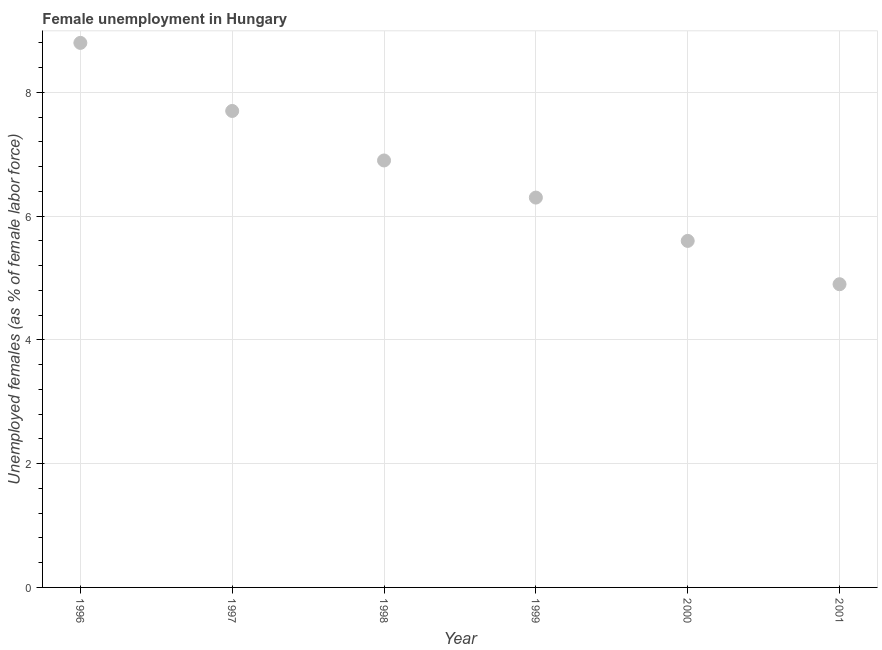What is the unemployed females population in 1999?
Your answer should be compact. 6.3. Across all years, what is the maximum unemployed females population?
Your answer should be compact. 8.8. Across all years, what is the minimum unemployed females population?
Provide a short and direct response. 4.9. What is the sum of the unemployed females population?
Give a very brief answer. 40.2. What is the difference between the unemployed females population in 1996 and 2001?
Ensure brevity in your answer.  3.9. What is the average unemployed females population per year?
Provide a succinct answer. 6.7. What is the median unemployed females population?
Your response must be concise. 6.6. In how many years, is the unemployed females population greater than 5.2 %?
Provide a succinct answer. 5. What is the ratio of the unemployed females population in 1999 to that in 2001?
Provide a succinct answer. 1.29. Is the unemployed females population in 1997 less than that in 1998?
Keep it short and to the point. No. What is the difference between the highest and the second highest unemployed females population?
Your answer should be compact. 1.1. Is the sum of the unemployed females population in 1997 and 1998 greater than the maximum unemployed females population across all years?
Provide a short and direct response. Yes. What is the difference between the highest and the lowest unemployed females population?
Your response must be concise. 3.9. In how many years, is the unemployed females population greater than the average unemployed females population taken over all years?
Offer a very short reply. 3. Does the unemployed females population monotonically increase over the years?
Your answer should be very brief. No. How many dotlines are there?
Offer a very short reply. 1. What is the difference between two consecutive major ticks on the Y-axis?
Provide a short and direct response. 2. What is the title of the graph?
Ensure brevity in your answer.  Female unemployment in Hungary. What is the label or title of the Y-axis?
Provide a short and direct response. Unemployed females (as % of female labor force). What is the Unemployed females (as % of female labor force) in 1996?
Your answer should be very brief. 8.8. What is the Unemployed females (as % of female labor force) in 1997?
Your answer should be very brief. 7.7. What is the Unemployed females (as % of female labor force) in 1998?
Provide a short and direct response. 6.9. What is the Unemployed females (as % of female labor force) in 1999?
Give a very brief answer. 6.3. What is the Unemployed females (as % of female labor force) in 2000?
Your answer should be compact. 5.6. What is the Unemployed females (as % of female labor force) in 2001?
Provide a short and direct response. 4.9. What is the difference between the Unemployed females (as % of female labor force) in 1996 and 1999?
Offer a terse response. 2.5. What is the difference between the Unemployed females (as % of female labor force) in 1996 and 2000?
Provide a short and direct response. 3.2. What is the difference between the Unemployed females (as % of female labor force) in 1997 and 2000?
Give a very brief answer. 2.1. What is the difference between the Unemployed females (as % of female labor force) in 1997 and 2001?
Give a very brief answer. 2.8. What is the difference between the Unemployed females (as % of female labor force) in 1998 and 2000?
Provide a short and direct response. 1.3. What is the difference between the Unemployed females (as % of female labor force) in 1999 and 2000?
Your answer should be compact. 0.7. What is the difference between the Unemployed females (as % of female labor force) in 2000 and 2001?
Provide a succinct answer. 0.7. What is the ratio of the Unemployed females (as % of female labor force) in 1996 to that in 1997?
Ensure brevity in your answer.  1.14. What is the ratio of the Unemployed females (as % of female labor force) in 1996 to that in 1998?
Provide a succinct answer. 1.27. What is the ratio of the Unemployed females (as % of female labor force) in 1996 to that in 1999?
Ensure brevity in your answer.  1.4. What is the ratio of the Unemployed females (as % of female labor force) in 1996 to that in 2000?
Your response must be concise. 1.57. What is the ratio of the Unemployed females (as % of female labor force) in 1996 to that in 2001?
Give a very brief answer. 1.8. What is the ratio of the Unemployed females (as % of female labor force) in 1997 to that in 1998?
Your answer should be compact. 1.12. What is the ratio of the Unemployed females (as % of female labor force) in 1997 to that in 1999?
Your answer should be very brief. 1.22. What is the ratio of the Unemployed females (as % of female labor force) in 1997 to that in 2000?
Give a very brief answer. 1.38. What is the ratio of the Unemployed females (as % of female labor force) in 1997 to that in 2001?
Ensure brevity in your answer.  1.57. What is the ratio of the Unemployed females (as % of female labor force) in 1998 to that in 1999?
Provide a succinct answer. 1.09. What is the ratio of the Unemployed females (as % of female labor force) in 1998 to that in 2000?
Your answer should be compact. 1.23. What is the ratio of the Unemployed females (as % of female labor force) in 1998 to that in 2001?
Ensure brevity in your answer.  1.41. What is the ratio of the Unemployed females (as % of female labor force) in 1999 to that in 2000?
Your response must be concise. 1.12. What is the ratio of the Unemployed females (as % of female labor force) in 1999 to that in 2001?
Your answer should be very brief. 1.29. What is the ratio of the Unemployed females (as % of female labor force) in 2000 to that in 2001?
Ensure brevity in your answer.  1.14. 